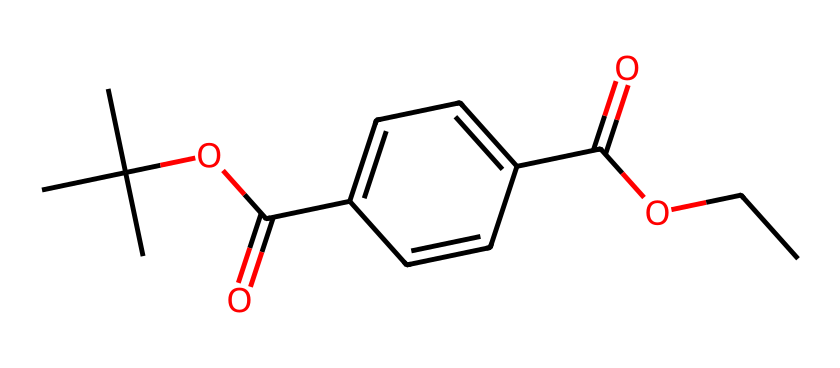What is the functional group present in this chemical? The chemical structure has a carboxylic acid group (-COOH) indicated by the presence of the –C(=O)O portion, which confirms it's a functional group in the molecule.
Answer: carboxylic acid How many carbon atoms are in the structure? By examining the SMILES representation, each 'C' denotes a carbon atom. Counting the 'C's in the structure gives a total of 10 carbon atoms.
Answer: 10 What type of polymer is represented by this structure? The structure includes repeating units typical for conventional plastics. PET is recognized as a thermoplastic polyester, which indicates the type of polymer it represents.
Answer: polyester What is the degree of saturation of the compound? The presence of double bonds (C=O and C=C can be inferred), and by reviewing the structure, we can conclude that it is unsaturated due to these double bonds.
Answer: unsaturated How many ester linkages are found in the chemical structure? In the representation, the ester groups can be identified by looking for –COO– connections, which appear twice in this structure, indicating the presence of two ester linkages.
Answer: 2 What type of bond connects carbon atoms in this structure? The bonds connecting the carbon atoms within this structure are primarily single covalent bonds, typical for saturated and unsaturated carbon chains and rings.
Answer: single covalent bonds What is the primary use of polyethylene terephthalate in containers? Polyethylene terephthalate (PET) is primarily used for making plastic containers, especially for food and beverage storage, due to its favorable properties such as clarity, strength, and recyclability.
Answer: storage containers 